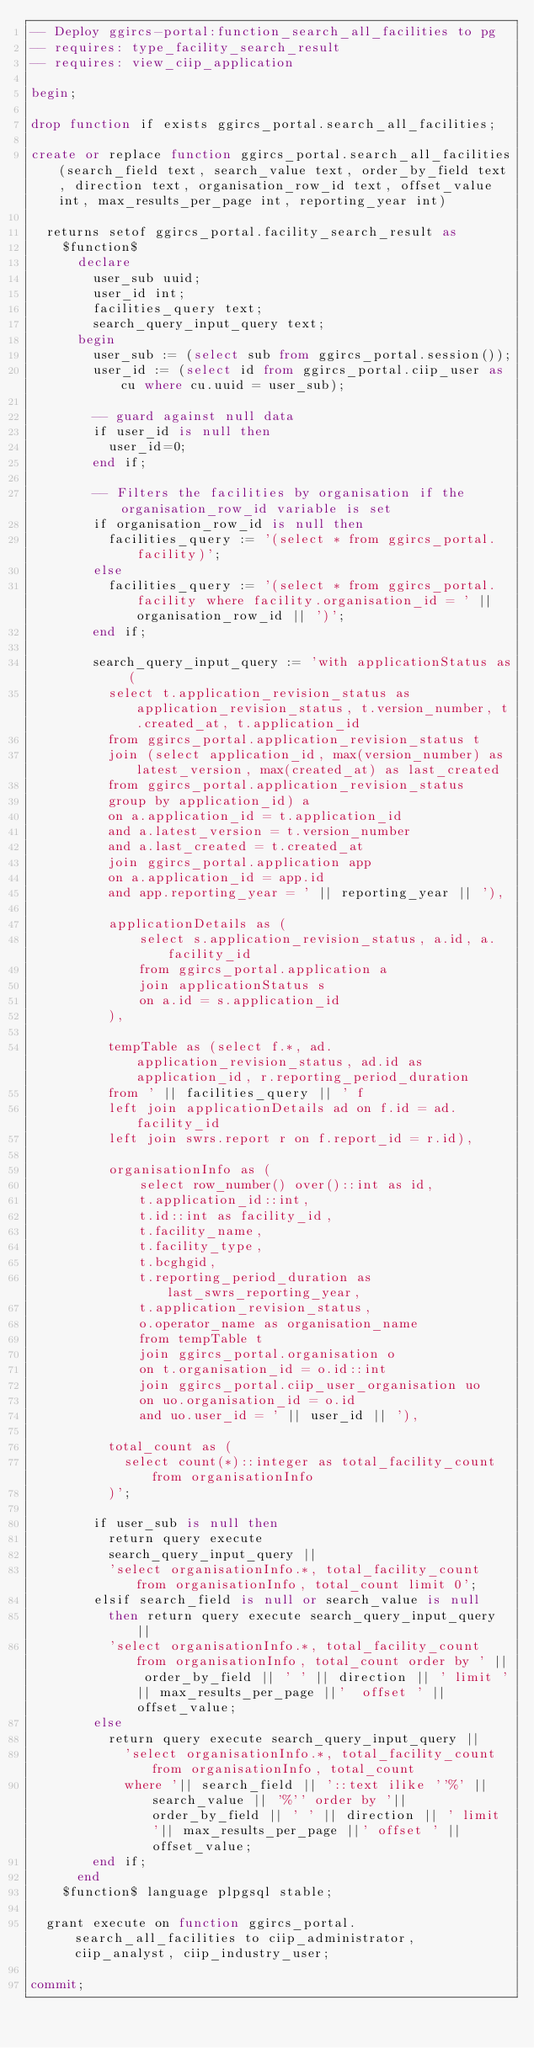Convert code to text. <code><loc_0><loc_0><loc_500><loc_500><_SQL_>-- Deploy ggircs-portal:function_search_all_facilities to pg
-- requires: type_facility_search_result
-- requires: view_ciip_application

begin;

drop function if exists ggircs_portal.search_all_facilities;

create or replace function ggircs_portal.search_all_facilities(search_field text, search_value text, order_by_field text, direction text, organisation_row_id text, offset_value int, max_results_per_page int, reporting_year int)

  returns setof ggircs_portal.facility_search_result as
    $function$
      declare
        user_sub uuid;
        user_id int;
        facilities_query text;
        search_query_input_query text;
      begin
        user_sub := (select sub from ggircs_portal.session());
        user_id := (select id from ggircs_portal.ciip_user as cu where cu.uuid = user_sub);

        -- guard against null data
        if user_id is null then
          user_id=0;
        end if;

        -- Filters the facilities by organisation if the organisation_row_id variable is set
        if organisation_row_id is null then
          facilities_query := '(select * from ggircs_portal.facility)';
        else
          facilities_query := '(select * from ggircs_portal.facility where facility.organisation_id = ' || organisation_row_id || ')';
        end if;

        search_query_input_query := 'with applicationStatus as (
          select t.application_revision_status as application_revision_status, t.version_number, t.created_at, t.application_id
          from ggircs_portal.application_revision_status t
          join (select application_id, max(version_number) as latest_version, max(created_at) as last_created
          from ggircs_portal.application_revision_status
          group by application_id) a
          on a.application_id = t.application_id
          and a.latest_version = t.version_number
          and a.last_created = t.created_at
          join ggircs_portal.application app
          on a.application_id = app.id
          and app.reporting_year = ' || reporting_year || '),

          applicationDetails as (
              select s.application_revision_status, a.id, a.facility_id
              from ggircs_portal.application a
              join applicationStatus s
              on a.id = s.application_id
          ),

          tempTable as (select f.*, ad.application_revision_status, ad.id as application_id, r.reporting_period_duration
          from ' || facilities_query || ' f
          left join applicationDetails ad on f.id = ad.facility_id
          left join swrs.report r on f.report_id = r.id),

          organisationInfo as (
              select row_number() over()::int as id,
              t.application_id::int,
              t.id::int as facility_id,
              t.facility_name,
              t.facility_type,
              t.bcghgid,
              t.reporting_period_duration as last_swrs_reporting_year,
              t.application_revision_status,
              o.operator_name as organisation_name
              from tempTable t
              join ggircs_portal.organisation o
              on t.organisation_id = o.id::int
              join ggircs_portal.ciip_user_organisation uo
              on uo.organisation_id = o.id
              and uo.user_id = ' || user_id || '),

          total_count as (
            select count(*)::integer as total_facility_count from organisationInfo
          )';

        if user_sub is null then
          return query execute
          search_query_input_query ||
          'select organisationInfo.*, total_facility_count from organisationInfo, total_count limit 0';
        elsif search_field is null or search_value is null
          then return query execute search_query_input_query ||
          'select organisationInfo.*, total_facility_count from organisationInfo, total_count order by ' || order_by_field || ' ' || direction || ' limit '|| max_results_per_page ||'  offset ' || offset_value;
        else
          return query execute search_query_input_query ||
            'select organisationInfo.*, total_facility_count from organisationInfo, total_count
            where '|| search_field || '::text ilike ''%' || search_value || '%'' order by '|| order_by_field || ' ' || direction || ' limit '|| max_results_per_page ||' offset ' || offset_value;
        end if;
      end
    $function$ language plpgsql stable;

  grant execute on function ggircs_portal.search_all_facilities to ciip_administrator, ciip_analyst, ciip_industry_user;

commit;
</code> 